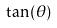Convert formula to latex. <formula><loc_0><loc_0><loc_500><loc_500>\tan ( \theta )</formula> 